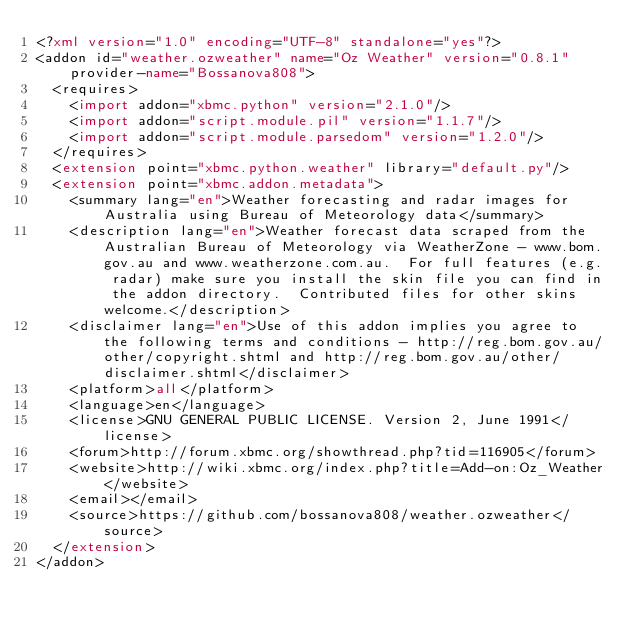Convert code to text. <code><loc_0><loc_0><loc_500><loc_500><_XML_><?xml version="1.0" encoding="UTF-8" standalone="yes"?>
<addon id="weather.ozweather" name="Oz Weather" version="0.8.1" provider-name="Bossanova808">
	<requires>
		<import addon="xbmc.python" version="2.1.0"/>
		<import addon="script.module.pil" version="1.1.7"/>
    <import addon="script.module.parsedom" version="1.2.0"/>
	</requires>
	<extension point="xbmc.python.weather" library="default.py"/>
	<extension point="xbmc.addon.metadata">
		<summary lang="en">Weather forecasting and radar images for Australia using Bureau of Meteorology data</summary>
		<description lang="en">Weather forecast data scraped from the Australian Bureau of Meteorology via WeatherZone - www.bom.gov.au and www.weatherzone.com.au.  For full features (e.g. radar) make sure you install the skin file you can find in the addon directory.  Contributed files for other skins welcome.</description>
		<disclaimer lang="en">Use of this addon implies you agree to the following terms and conditions - http://reg.bom.gov.au/other/copyright.shtml and http://reg.bom.gov.au/other/disclaimer.shtml</disclaimer>
		<platform>all</platform>
		<language>en</language>
		<license>GNU GENERAL PUBLIC LICENSE. Version 2, June 1991</license>
		<forum>http://forum.xbmc.org/showthread.php?tid=116905</forum>
		<website>http://wiki.xbmc.org/index.php?title=Add-on:Oz_Weather</website>
		<email></email>
		<source>https://github.com/bossanova808/weather.ozweather</source>
	</extension>
</addon>
</code> 